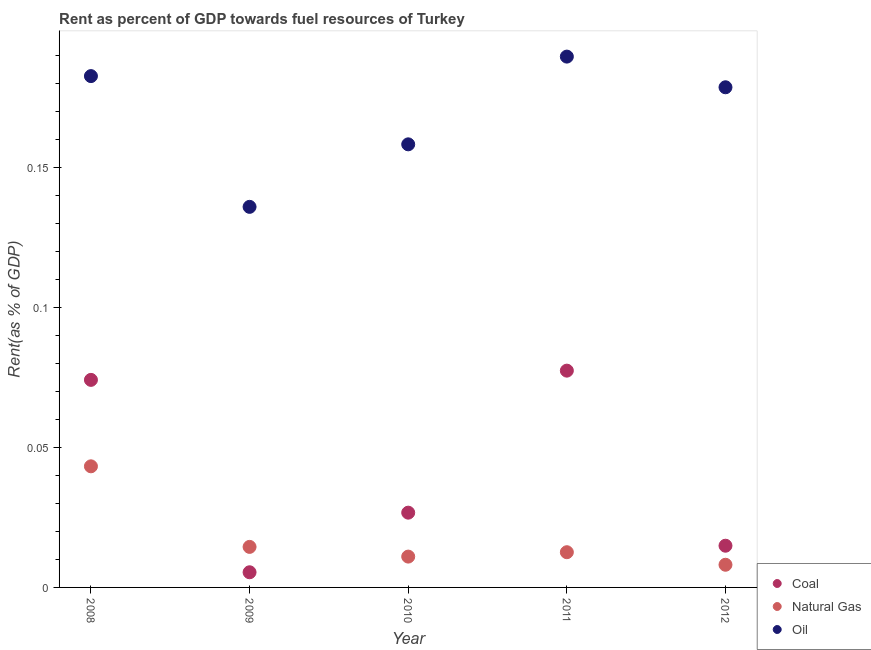How many different coloured dotlines are there?
Offer a very short reply. 3. What is the rent towards coal in 2008?
Your response must be concise. 0.07. Across all years, what is the maximum rent towards oil?
Offer a terse response. 0.19. Across all years, what is the minimum rent towards natural gas?
Offer a very short reply. 0.01. What is the total rent towards oil in the graph?
Your response must be concise. 0.85. What is the difference between the rent towards coal in 2009 and that in 2010?
Keep it short and to the point. -0.02. What is the difference between the rent towards coal in 2012 and the rent towards natural gas in 2008?
Provide a succinct answer. -0.03. What is the average rent towards natural gas per year?
Your answer should be very brief. 0.02. In the year 2009, what is the difference between the rent towards coal and rent towards oil?
Your answer should be compact. -0.13. In how many years, is the rent towards oil greater than 0.1 %?
Your response must be concise. 5. What is the ratio of the rent towards oil in 2008 to that in 2010?
Provide a succinct answer. 1.15. Is the rent towards oil in 2009 less than that in 2012?
Offer a terse response. Yes. Is the difference between the rent towards coal in 2009 and 2010 greater than the difference between the rent towards natural gas in 2009 and 2010?
Your response must be concise. No. What is the difference between the highest and the second highest rent towards oil?
Provide a short and direct response. 0.01. What is the difference between the highest and the lowest rent towards oil?
Ensure brevity in your answer.  0.05. Is the sum of the rent towards natural gas in 2008 and 2009 greater than the maximum rent towards coal across all years?
Provide a short and direct response. No. Is it the case that in every year, the sum of the rent towards coal and rent towards natural gas is greater than the rent towards oil?
Offer a very short reply. No. Does the rent towards natural gas monotonically increase over the years?
Make the answer very short. No. Is the rent towards natural gas strictly greater than the rent towards coal over the years?
Provide a short and direct response. No. Is the rent towards coal strictly less than the rent towards oil over the years?
Provide a succinct answer. Yes. How many dotlines are there?
Provide a short and direct response. 3. How many years are there in the graph?
Offer a terse response. 5. What is the difference between two consecutive major ticks on the Y-axis?
Your answer should be very brief. 0.05. Does the graph contain grids?
Your response must be concise. No. Where does the legend appear in the graph?
Offer a terse response. Bottom right. How are the legend labels stacked?
Your answer should be very brief. Vertical. What is the title of the graph?
Your answer should be compact. Rent as percent of GDP towards fuel resources of Turkey. Does "Manufactures" appear as one of the legend labels in the graph?
Give a very brief answer. No. What is the label or title of the Y-axis?
Your answer should be very brief. Rent(as % of GDP). What is the Rent(as % of GDP) of Coal in 2008?
Offer a terse response. 0.07. What is the Rent(as % of GDP) of Natural Gas in 2008?
Offer a terse response. 0.04. What is the Rent(as % of GDP) of Oil in 2008?
Your answer should be very brief. 0.18. What is the Rent(as % of GDP) of Coal in 2009?
Keep it short and to the point. 0.01. What is the Rent(as % of GDP) in Natural Gas in 2009?
Offer a terse response. 0.01. What is the Rent(as % of GDP) of Oil in 2009?
Provide a short and direct response. 0.14. What is the Rent(as % of GDP) in Coal in 2010?
Your answer should be compact. 0.03. What is the Rent(as % of GDP) in Natural Gas in 2010?
Your answer should be compact. 0.01. What is the Rent(as % of GDP) in Oil in 2010?
Provide a succinct answer. 0.16. What is the Rent(as % of GDP) in Coal in 2011?
Your answer should be very brief. 0.08. What is the Rent(as % of GDP) in Natural Gas in 2011?
Offer a very short reply. 0.01. What is the Rent(as % of GDP) of Oil in 2011?
Keep it short and to the point. 0.19. What is the Rent(as % of GDP) in Coal in 2012?
Your answer should be compact. 0.01. What is the Rent(as % of GDP) of Natural Gas in 2012?
Your answer should be compact. 0.01. What is the Rent(as % of GDP) in Oil in 2012?
Offer a very short reply. 0.18. Across all years, what is the maximum Rent(as % of GDP) in Coal?
Make the answer very short. 0.08. Across all years, what is the maximum Rent(as % of GDP) of Natural Gas?
Ensure brevity in your answer.  0.04. Across all years, what is the maximum Rent(as % of GDP) of Oil?
Make the answer very short. 0.19. Across all years, what is the minimum Rent(as % of GDP) in Coal?
Keep it short and to the point. 0.01. Across all years, what is the minimum Rent(as % of GDP) in Natural Gas?
Your answer should be very brief. 0.01. Across all years, what is the minimum Rent(as % of GDP) in Oil?
Your answer should be compact. 0.14. What is the total Rent(as % of GDP) of Coal in the graph?
Provide a succinct answer. 0.2. What is the total Rent(as % of GDP) in Natural Gas in the graph?
Ensure brevity in your answer.  0.09. What is the total Rent(as % of GDP) of Oil in the graph?
Provide a succinct answer. 0.85. What is the difference between the Rent(as % of GDP) of Coal in 2008 and that in 2009?
Your answer should be compact. 0.07. What is the difference between the Rent(as % of GDP) of Natural Gas in 2008 and that in 2009?
Offer a very short reply. 0.03. What is the difference between the Rent(as % of GDP) in Oil in 2008 and that in 2009?
Give a very brief answer. 0.05. What is the difference between the Rent(as % of GDP) of Coal in 2008 and that in 2010?
Your answer should be compact. 0.05. What is the difference between the Rent(as % of GDP) in Natural Gas in 2008 and that in 2010?
Your response must be concise. 0.03. What is the difference between the Rent(as % of GDP) in Oil in 2008 and that in 2010?
Ensure brevity in your answer.  0.02. What is the difference between the Rent(as % of GDP) of Coal in 2008 and that in 2011?
Provide a short and direct response. -0. What is the difference between the Rent(as % of GDP) of Natural Gas in 2008 and that in 2011?
Give a very brief answer. 0.03. What is the difference between the Rent(as % of GDP) in Oil in 2008 and that in 2011?
Provide a succinct answer. -0.01. What is the difference between the Rent(as % of GDP) of Coal in 2008 and that in 2012?
Ensure brevity in your answer.  0.06. What is the difference between the Rent(as % of GDP) of Natural Gas in 2008 and that in 2012?
Your answer should be compact. 0.04. What is the difference between the Rent(as % of GDP) of Oil in 2008 and that in 2012?
Offer a terse response. 0. What is the difference between the Rent(as % of GDP) in Coal in 2009 and that in 2010?
Offer a very short reply. -0.02. What is the difference between the Rent(as % of GDP) in Natural Gas in 2009 and that in 2010?
Make the answer very short. 0. What is the difference between the Rent(as % of GDP) of Oil in 2009 and that in 2010?
Provide a short and direct response. -0.02. What is the difference between the Rent(as % of GDP) in Coal in 2009 and that in 2011?
Your answer should be very brief. -0.07. What is the difference between the Rent(as % of GDP) of Natural Gas in 2009 and that in 2011?
Keep it short and to the point. 0. What is the difference between the Rent(as % of GDP) of Oil in 2009 and that in 2011?
Your response must be concise. -0.05. What is the difference between the Rent(as % of GDP) of Coal in 2009 and that in 2012?
Give a very brief answer. -0.01. What is the difference between the Rent(as % of GDP) of Natural Gas in 2009 and that in 2012?
Keep it short and to the point. 0.01. What is the difference between the Rent(as % of GDP) of Oil in 2009 and that in 2012?
Keep it short and to the point. -0.04. What is the difference between the Rent(as % of GDP) in Coal in 2010 and that in 2011?
Keep it short and to the point. -0.05. What is the difference between the Rent(as % of GDP) in Natural Gas in 2010 and that in 2011?
Give a very brief answer. -0. What is the difference between the Rent(as % of GDP) in Oil in 2010 and that in 2011?
Give a very brief answer. -0.03. What is the difference between the Rent(as % of GDP) in Coal in 2010 and that in 2012?
Offer a very short reply. 0.01. What is the difference between the Rent(as % of GDP) in Natural Gas in 2010 and that in 2012?
Make the answer very short. 0. What is the difference between the Rent(as % of GDP) in Oil in 2010 and that in 2012?
Ensure brevity in your answer.  -0.02. What is the difference between the Rent(as % of GDP) in Coal in 2011 and that in 2012?
Provide a short and direct response. 0.06. What is the difference between the Rent(as % of GDP) of Natural Gas in 2011 and that in 2012?
Provide a short and direct response. 0. What is the difference between the Rent(as % of GDP) of Oil in 2011 and that in 2012?
Ensure brevity in your answer.  0.01. What is the difference between the Rent(as % of GDP) of Coal in 2008 and the Rent(as % of GDP) of Natural Gas in 2009?
Provide a succinct answer. 0.06. What is the difference between the Rent(as % of GDP) of Coal in 2008 and the Rent(as % of GDP) of Oil in 2009?
Offer a terse response. -0.06. What is the difference between the Rent(as % of GDP) in Natural Gas in 2008 and the Rent(as % of GDP) in Oil in 2009?
Your response must be concise. -0.09. What is the difference between the Rent(as % of GDP) in Coal in 2008 and the Rent(as % of GDP) in Natural Gas in 2010?
Ensure brevity in your answer.  0.06. What is the difference between the Rent(as % of GDP) in Coal in 2008 and the Rent(as % of GDP) in Oil in 2010?
Your answer should be compact. -0.08. What is the difference between the Rent(as % of GDP) in Natural Gas in 2008 and the Rent(as % of GDP) in Oil in 2010?
Ensure brevity in your answer.  -0.12. What is the difference between the Rent(as % of GDP) in Coal in 2008 and the Rent(as % of GDP) in Natural Gas in 2011?
Give a very brief answer. 0.06. What is the difference between the Rent(as % of GDP) in Coal in 2008 and the Rent(as % of GDP) in Oil in 2011?
Offer a terse response. -0.12. What is the difference between the Rent(as % of GDP) in Natural Gas in 2008 and the Rent(as % of GDP) in Oil in 2011?
Provide a short and direct response. -0.15. What is the difference between the Rent(as % of GDP) of Coal in 2008 and the Rent(as % of GDP) of Natural Gas in 2012?
Make the answer very short. 0.07. What is the difference between the Rent(as % of GDP) of Coal in 2008 and the Rent(as % of GDP) of Oil in 2012?
Give a very brief answer. -0.1. What is the difference between the Rent(as % of GDP) in Natural Gas in 2008 and the Rent(as % of GDP) in Oil in 2012?
Provide a short and direct response. -0.14. What is the difference between the Rent(as % of GDP) of Coal in 2009 and the Rent(as % of GDP) of Natural Gas in 2010?
Offer a terse response. -0.01. What is the difference between the Rent(as % of GDP) of Coal in 2009 and the Rent(as % of GDP) of Oil in 2010?
Make the answer very short. -0.15. What is the difference between the Rent(as % of GDP) of Natural Gas in 2009 and the Rent(as % of GDP) of Oil in 2010?
Make the answer very short. -0.14. What is the difference between the Rent(as % of GDP) of Coal in 2009 and the Rent(as % of GDP) of Natural Gas in 2011?
Ensure brevity in your answer.  -0.01. What is the difference between the Rent(as % of GDP) in Coal in 2009 and the Rent(as % of GDP) in Oil in 2011?
Provide a succinct answer. -0.18. What is the difference between the Rent(as % of GDP) in Natural Gas in 2009 and the Rent(as % of GDP) in Oil in 2011?
Your answer should be compact. -0.18. What is the difference between the Rent(as % of GDP) in Coal in 2009 and the Rent(as % of GDP) in Natural Gas in 2012?
Keep it short and to the point. -0. What is the difference between the Rent(as % of GDP) of Coal in 2009 and the Rent(as % of GDP) of Oil in 2012?
Keep it short and to the point. -0.17. What is the difference between the Rent(as % of GDP) of Natural Gas in 2009 and the Rent(as % of GDP) of Oil in 2012?
Offer a very short reply. -0.16. What is the difference between the Rent(as % of GDP) in Coal in 2010 and the Rent(as % of GDP) in Natural Gas in 2011?
Give a very brief answer. 0.01. What is the difference between the Rent(as % of GDP) in Coal in 2010 and the Rent(as % of GDP) in Oil in 2011?
Offer a terse response. -0.16. What is the difference between the Rent(as % of GDP) of Natural Gas in 2010 and the Rent(as % of GDP) of Oil in 2011?
Your response must be concise. -0.18. What is the difference between the Rent(as % of GDP) in Coal in 2010 and the Rent(as % of GDP) in Natural Gas in 2012?
Offer a terse response. 0.02. What is the difference between the Rent(as % of GDP) in Coal in 2010 and the Rent(as % of GDP) in Oil in 2012?
Offer a terse response. -0.15. What is the difference between the Rent(as % of GDP) of Natural Gas in 2010 and the Rent(as % of GDP) of Oil in 2012?
Your response must be concise. -0.17. What is the difference between the Rent(as % of GDP) of Coal in 2011 and the Rent(as % of GDP) of Natural Gas in 2012?
Provide a short and direct response. 0.07. What is the difference between the Rent(as % of GDP) in Coal in 2011 and the Rent(as % of GDP) in Oil in 2012?
Offer a very short reply. -0.1. What is the difference between the Rent(as % of GDP) of Natural Gas in 2011 and the Rent(as % of GDP) of Oil in 2012?
Your answer should be very brief. -0.17. What is the average Rent(as % of GDP) of Coal per year?
Your answer should be compact. 0.04. What is the average Rent(as % of GDP) in Natural Gas per year?
Offer a terse response. 0.02. What is the average Rent(as % of GDP) of Oil per year?
Provide a short and direct response. 0.17. In the year 2008, what is the difference between the Rent(as % of GDP) of Coal and Rent(as % of GDP) of Natural Gas?
Offer a very short reply. 0.03. In the year 2008, what is the difference between the Rent(as % of GDP) in Coal and Rent(as % of GDP) in Oil?
Ensure brevity in your answer.  -0.11. In the year 2008, what is the difference between the Rent(as % of GDP) in Natural Gas and Rent(as % of GDP) in Oil?
Offer a very short reply. -0.14. In the year 2009, what is the difference between the Rent(as % of GDP) in Coal and Rent(as % of GDP) in Natural Gas?
Ensure brevity in your answer.  -0.01. In the year 2009, what is the difference between the Rent(as % of GDP) in Coal and Rent(as % of GDP) in Oil?
Offer a terse response. -0.13. In the year 2009, what is the difference between the Rent(as % of GDP) in Natural Gas and Rent(as % of GDP) in Oil?
Ensure brevity in your answer.  -0.12. In the year 2010, what is the difference between the Rent(as % of GDP) of Coal and Rent(as % of GDP) of Natural Gas?
Ensure brevity in your answer.  0.02. In the year 2010, what is the difference between the Rent(as % of GDP) of Coal and Rent(as % of GDP) of Oil?
Ensure brevity in your answer.  -0.13. In the year 2010, what is the difference between the Rent(as % of GDP) of Natural Gas and Rent(as % of GDP) of Oil?
Give a very brief answer. -0.15. In the year 2011, what is the difference between the Rent(as % of GDP) of Coal and Rent(as % of GDP) of Natural Gas?
Your answer should be compact. 0.06. In the year 2011, what is the difference between the Rent(as % of GDP) in Coal and Rent(as % of GDP) in Oil?
Your answer should be very brief. -0.11. In the year 2011, what is the difference between the Rent(as % of GDP) in Natural Gas and Rent(as % of GDP) in Oil?
Offer a terse response. -0.18. In the year 2012, what is the difference between the Rent(as % of GDP) of Coal and Rent(as % of GDP) of Natural Gas?
Make the answer very short. 0.01. In the year 2012, what is the difference between the Rent(as % of GDP) of Coal and Rent(as % of GDP) of Oil?
Provide a short and direct response. -0.16. In the year 2012, what is the difference between the Rent(as % of GDP) in Natural Gas and Rent(as % of GDP) in Oil?
Keep it short and to the point. -0.17. What is the ratio of the Rent(as % of GDP) of Coal in 2008 to that in 2009?
Make the answer very short. 13.69. What is the ratio of the Rent(as % of GDP) in Natural Gas in 2008 to that in 2009?
Provide a short and direct response. 2.99. What is the ratio of the Rent(as % of GDP) of Oil in 2008 to that in 2009?
Provide a succinct answer. 1.34. What is the ratio of the Rent(as % of GDP) of Coal in 2008 to that in 2010?
Keep it short and to the point. 2.78. What is the ratio of the Rent(as % of GDP) of Natural Gas in 2008 to that in 2010?
Give a very brief answer. 3.93. What is the ratio of the Rent(as % of GDP) of Oil in 2008 to that in 2010?
Provide a short and direct response. 1.15. What is the ratio of the Rent(as % of GDP) in Coal in 2008 to that in 2011?
Your answer should be very brief. 0.96. What is the ratio of the Rent(as % of GDP) of Natural Gas in 2008 to that in 2011?
Your answer should be compact. 3.44. What is the ratio of the Rent(as % of GDP) in Oil in 2008 to that in 2011?
Give a very brief answer. 0.96. What is the ratio of the Rent(as % of GDP) in Coal in 2008 to that in 2012?
Your answer should be compact. 4.98. What is the ratio of the Rent(as % of GDP) of Natural Gas in 2008 to that in 2012?
Your response must be concise. 5.34. What is the ratio of the Rent(as % of GDP) of Oil in 2008 to that in 2012?
Keep it short and to the point. 1.02. What is the ratio of the Rent(as % of GDP) in Coal in 2009 to that in 2010?
Provide a short and direct response. 0.2. What is the ratio of the Rent(as % of GDP) in Natural Gas in 2009 to that in 2010?
Make the answer very short. 1.31. What is the ratio of the Rent(as % of GDP) in Oil in 2009 to that in 2010?
Make the answer very short. 0.86. What is the ratio of the Rent(as % of GDP) in Coal in 2009 to that in 2011?
Ensure brevity in your answer.  0.07. What is the ratio of the Rent(as % of GDP) in Natural Gas in 2009 to that in 2011?
Keep it short and to the point. 1.15. What is the ratio of the Rent(as % of GDP) in Oil in 2009 to that in 2011?
Keep it short and to the point. 0.72. What is the ratio of the Rent(as % of GDP) of Coal in 2009 to that in 2012?
Your answer should be very brief. 0.36. What is the ratio of the Rent(as % of GDP) in Natural Gas in 2009 to that in 2012?
Offer a very short reply. 1.79. What is the ratio of the Rent(as % of GDP) in Oil in 2009 to that in 2012?
Keep it short and to the point. 0.76. What is the ratio of the Rent(as % of GDP) of Coal in 2010 to that in 2011?
Your response must be concise. 0.34. What is the ratio of the Rent(as % of GDP) of Natural Gas in 2010 to that in 2011?
Your response must be concise. 0.88. What is the ratio of the Rent(as % of GDP) of Oil in 2010 to that in 2011?
Offer a very short reply. 0.83. What is the ratio of the Rent(as % of GDP) in Coal in 2010 to that in 2012?
Your answer should be very brief. 1.79. What is the ratio of the Rent(as % of GDP) in Natural Gas in 2010 to that in 2012?
Your answer should be very brief. 1.36. What is the ratio of the Rent(as % of GDP) in Oil in 2010 to that in 2012?
Your answer should be compact. 0.89. What is the ratio of the Rent(as % of GDP) in Coal in 2011 to that in 2012?
Provide a short and direct response. 5.2. What is the ratio of the Rent(as % of GDP) in Natural Gas in 2011 to that in 2012?
Your answer should be compact. 1.55. What is the ratio of the Rent(as % of GDP) in Oil in 2011 to that in 2012?
Keep it short and to the point. 1.06. What is the difference between the highest and the second highest Rent(as % of GDP) in Coal?
Offer a terse response. 0. What is the difference between the highest and the second highest Rent(as % of GDP) in Natural Gas?
Provide a succinct answer. 0.03. What is the difference between the highest and the second highest Rent(as % of GDP) of Oil?
Your response must be concise. 0.01. What is the difference between the highest and the lowest Rent(as % of GDP) of Coal?
Keep it short and to the point. 0.07. What is the difference between the highest and the lowest Rent(as % of GDP) of Natural Gas?
Your response must be concise. 0.04. What is the difference between the highest and the lowest Rent(as % of GDP) of Oil?
Your answer should be very brief. 0.05. 